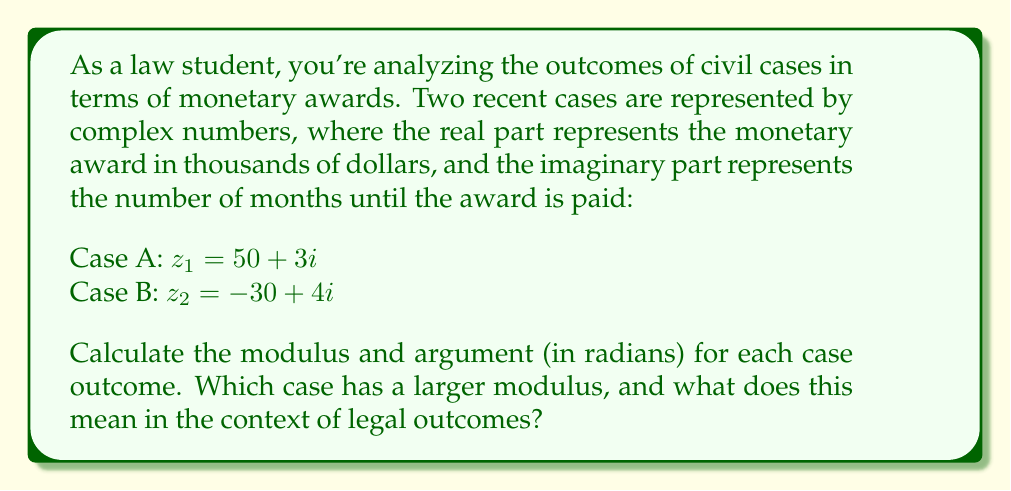Show me your answer to this math problem. To solve this problem, we need to calculate the modulus and argument for each complex number representing the case outcomes.

For a complex number $z = a + bi$, the modulus is given by:
$$|z| = \sqrt{a^2 + b^2}$$

And the argument (in radians) is given by:
$$\arg(z) = \tan^{-1}\left(\frac{b}{a}\right)$$

Note: For the argument, we need to consider the quadrant of the complex number to determine the correct angle.

Case A: $z_1 = 50 + 3i$

Modulus:
$$|z_1| = \sqrt{50^2 + 3^2} = \sqrt{2500 + 9} = \sqrt{2509} \approx 50.09$$

Argument:
$$\arg(z_1) = \tan^{-1}\left(\frac{3}{50}\right) \approx 0.0599 \text{ radians}$$

Case B: $z_2 = -30 + 4i$

Modulus:
$$|z_2| = \sqrt{(-30)^2 + 4^2} = \sqrt{900 + 16} = \sqrt{916} \approx 30.27$$

Argument:
$$\arg(z_2) = \pi + \tan^{-1}\left(\frac{4}{-30}\right) \approx 3.0027 \text{ radians}$$

Note: We add $\pi$ to the result of $\tan^{-1}$ for Case B because it's in the second quadrant.

Comparing the moduli:
$|z_1| \approx 50.09 > |z_2| \approx 30.27$

Case A has a larger modulus. In the context of legal outcomes, this means that Case A represents a more significant overall impact when considering both the monetary award and the time until payment. The larger modulus indicates a combination of a higher monetary award and/or a longer time until payment.
Answer: Case A: $|z_1| \approx 50.09$, $\arg(z_1) \approx 0.0599$ radians
Case B: $|z_2| \approx 30.27$, $\arg(z_2) \approx 3.0027$ radians

Case A has the larger modulus, indicating a more significant overall impact in terms of monetary award and time until payment. 